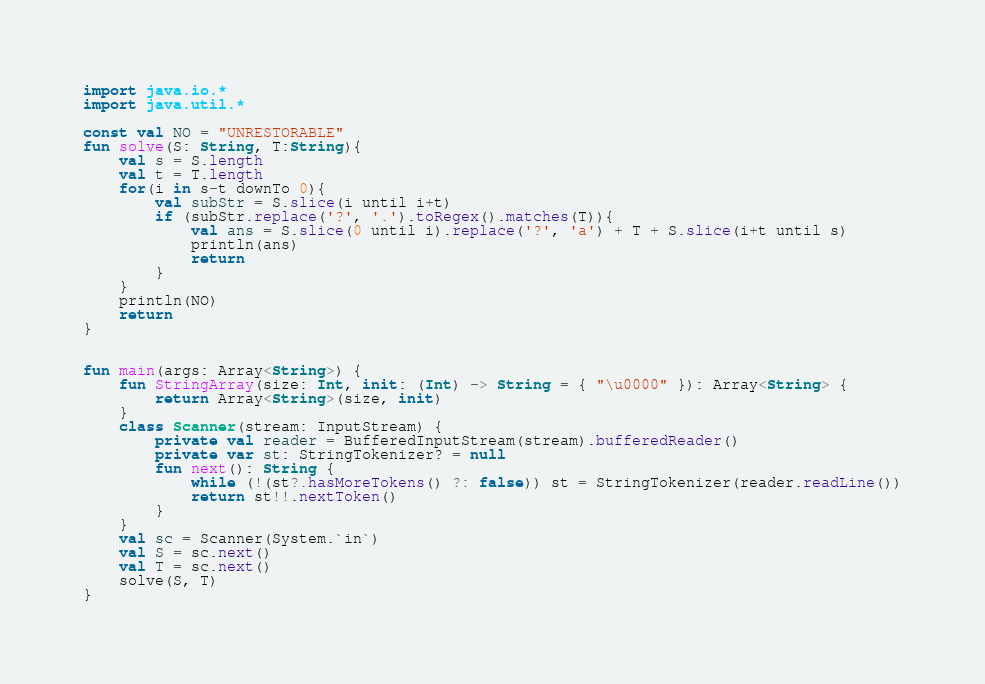<code> <loc_0><loc_0><loc_500><loc_500><_Kotlin_>import java.io.*
import java.util.*

const val NO = "UNRESTORABLE"
fun solve(S: String, T:String){
    val s = S.length
    val t = T.length
    for(i in s-t downTo 0){
        val subStr = S.slice(i until i+t)
        if (subStr.replace('?', '.').toRegex().matches(T)){
            val ans = S.slice(0 until i).replace('?', 'a') + T + S.slice(i+t until s)
            println(ans)
            return
        }
    }
    println(NO)
    return
}


fun main(args: Array<String>) {
    fun StringArray(size: Int, init: (Int) -> String = { "\u0000" }): Array<String> {
        return Array<String>(size, init)
    }
    class Scanner(stream: InputStream) {
        private val reader = BufferedInputStream(stream).bufferedReader()
        private var st: StringTokenizer? = null
        fun next(): String {
            while (!(st?.hasMoreTokens() ?: false)) st = StringTokenizer(reader.readLine())
            return st!!.nextToken()
        }
    }
    val sc = Scanner(System.`in`)
    val S = sc.next()
    val T = sc.next()
    solve(S, T)
}

</code> 